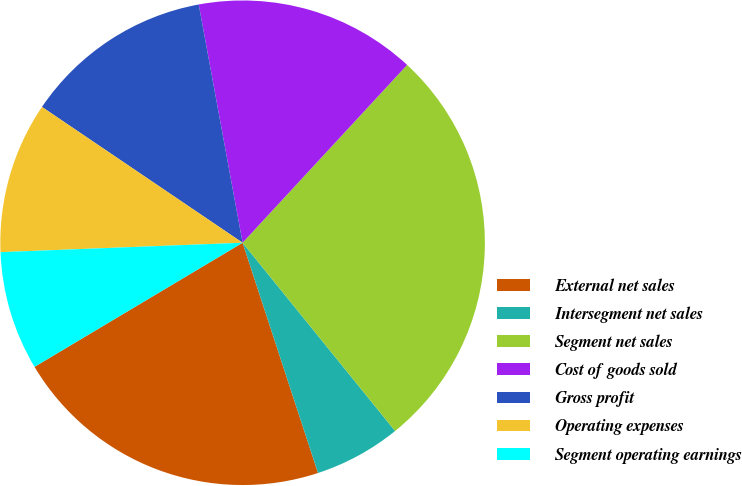Convert chart. <chart><loc_0><loc_0><loc_500><loc_500><pie_chart><fcel>External net sales<fcel>Intersegment net sales<fcel>Segment net sales<fcel>Cost of goods sold<fcel>Gross profit<fcel>Operating expenses<fcel>Segment operating earnings<nl><fcel>21.48%<fcel>5.8%<fcel>27.28%<fcel>14.78%<fcel>12.63%<fcel>10.09%<fcel>7.94%<nl></chart> 